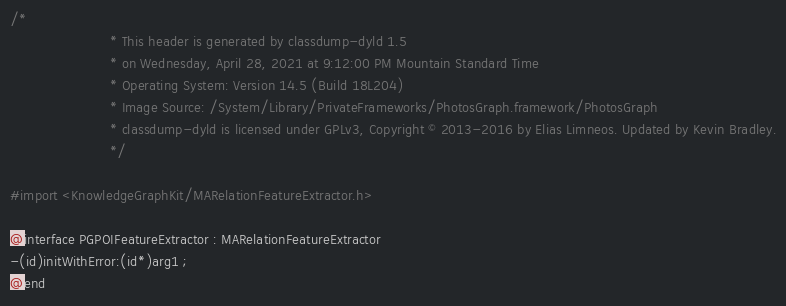<code> <loc_0><loc_0><loc_500><loc_500><_C_>/*
                       * This header is generated by classdump-dyld 1.5
                       * on Wednesday, April 28, 2021 at 9:12:00 PM Mountain Standard Time
                       * Operating System: Version 14.5 (Build 18L204)
                       * Image Source: /System/Library/PrivateFrameworks/PhotosGraph.framework/PhotosGraph
                       * classdump-dyld is licensed under GPLv3, Copyright © 2013-2016 by Elias Limneos. Updated by Kevin Bradley.
                       */

#import <KnowledgeGraphKit/MARelationFeatureExtractor.h>

@interface PGPOIFeatureExtractor : MARelationFeatureExtractor
-(id)initWithError:(id*)arg1 ;
@end

</code> 